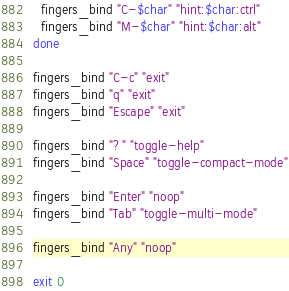<code> <loc_0><loc_0><loc_500><loc_500><_Bash_>  fingers_bind "C-$char" "hint:$char:ctrl"
  fingers_bind "M-$char" "hint:$char:alt"
done

fingers_bind "C-c" "exit"
fingers_bind "q" "exit"
fingers_bind "Escape" "exit"

fingers_bind "?" "toggle-help"
fingers_bind "Space" "toggle-compact-mode"

fingers_bind "Enter" "noop"
fingers_bind "Tab" "toggle-multi-mode"

fingers_bind "Any" "noop"

exit 0
</code> 